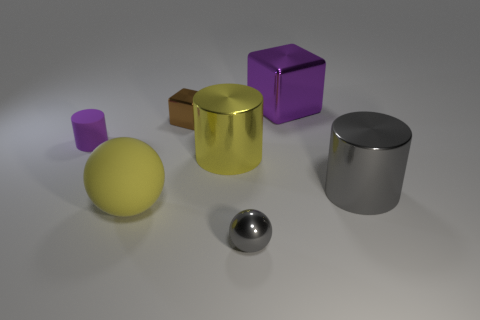Are there any large shiny cylinders that have the same color as the matte sphere?
Keep it short and to the point. Yes. There is a ball that is to the right of the tiny metal block; are there any shiny cylinders that are on the left side of it?
Provide a short and direct response. Yes. There is a purple metal cube; does it have the same size as the rubber thing that is on the right side of the purple rubber cylinder?
Offer a terse response. Yes. There is a tiny shiny object to the right of the small shiny object that is to the left of the large yellow metal cylinder; is there a object that is to the left of it?
Keep it short and to the point. Yes. What material is the cylinder in front of the big yellow metal cylinder?
Your answer should be very brief. Metal. Is the yellow matte object the same size as the yellow shiny cylinder?
Your response must be concise. Yes. The metallic object that is both in front of the big yellow metallic cylinder and behind the yellow matte object is what color?
Give a very brief answer. Gray. The big thing that is the same material as the small purple cylinder is what shape?
Your answer should be very brief. Sphere. What number of yellow objects are on the left side of the tiny block and right of the tiny brown shiny block?
Your answer should be very brief. 0. There is a rubber ball; are there any matte objects on the left side of it?
Give a very brief answer. Yes. 